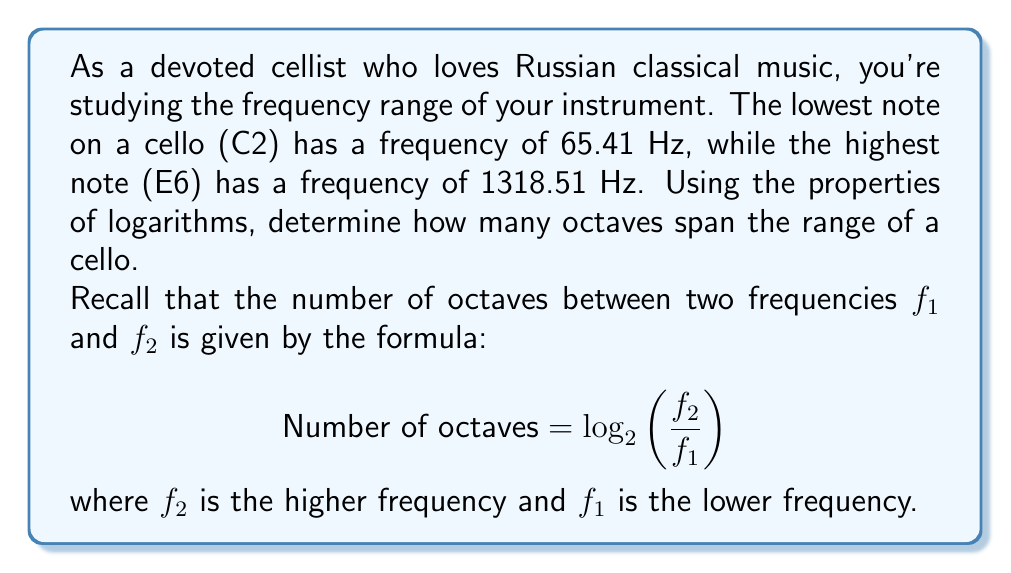Show me your answer to this math problem. Let's approach this step-by-step:

1) We are given:
   $f_1 = 65.41$ Hz (lowest note C2)
   $f_2 = 1318.51$ Hz (highest note E6)

2) We'll use the formula:
   $$ \text{Number of octaves} = \log_2\left(\frac{f_2}{f_1}\right) $$

3) Substituting our values:
   $$ \text{Number of octaves} = \log_2\left(\frac{1318.51}{65.41}\right) $$

4) Let's simplify the fraction inside the logarithm:
   $$ \text{Number of octaves} = \log_2(20.1576) $$

5) We can calculate this using the change of base formula:
   $$ \log_2(20.1576) = \frac{\log(20.1576)}{\log(2)} $$

6) Using a calculator:
   $$ \frac{\log(20.1576)}{\log(2)} \approx 4.3335 $$

7) Rounding to two decimal places:
   $$ \text{Number of octaves} \approx 4.33 $$

This means that the range of a cello spans approximately 4.33 octaves.
Answer: The cello's range spans approximately 4.33 octaves. 